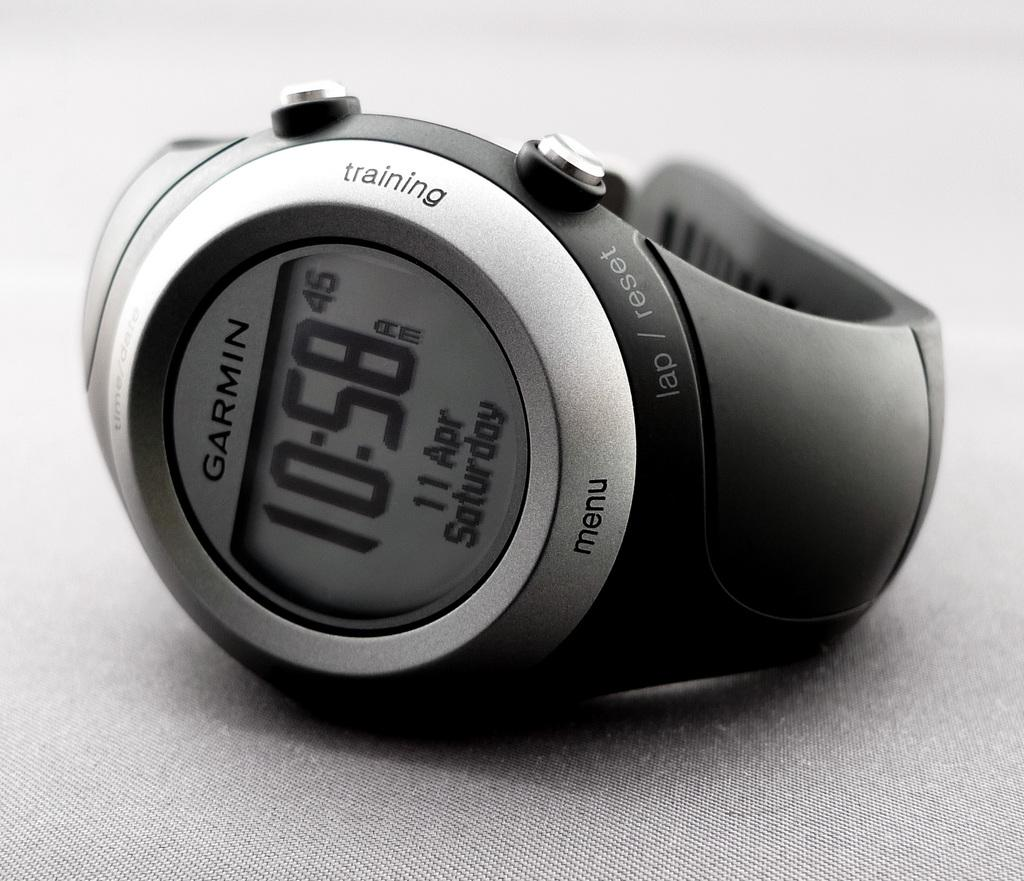<image>
Provide a brief description of the given image. A Garmin watch displays the time on a digital screen. 